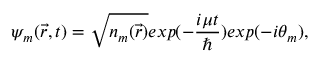<formula> <loc_0><loc_0><loc_500><loc_500>\psi _ { m } ( \vec { r } , t ) = \sqrt { n _ { m } ( \vec { r } ) } e x p ( - \frac { i \mu t } { } ) e x p ( - i \theta _ { m } ) ,</formula> 